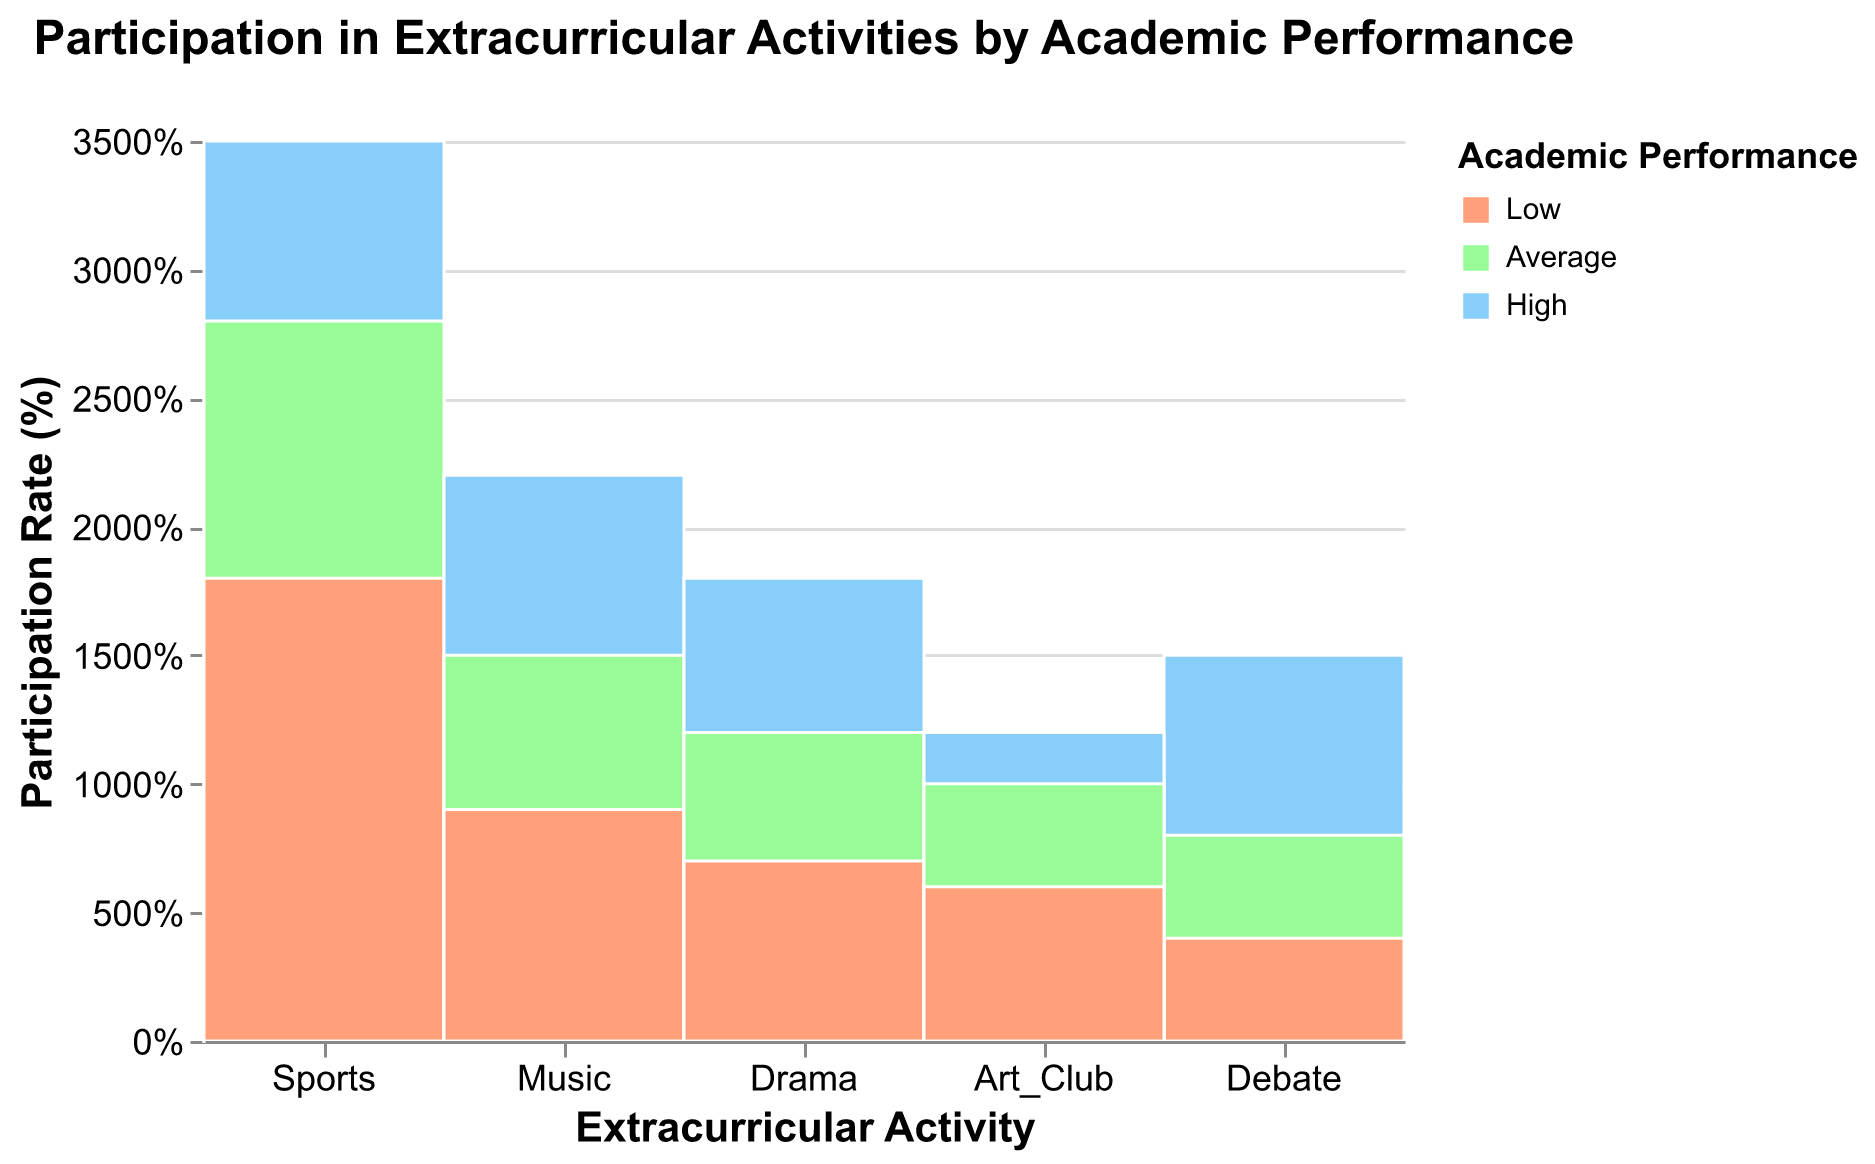What are the most common activities among students with high academic performance? To find the most common activities among students with high academic performance, look at the segments corresponding to 'High' academic performance in each 'Activity'. The height of these segments indicates the participation rate. Sports has the highest participation rate, followed by Music and Drama.
Answer: Sports Which activity has the highest participation rate for students with low academic performance? Look for the 'Low' academic performance segments in each activity column. The tallest segment indicates the highest participation rate for students with low academic performance, which is for Sports.
Answer: Sports How does the participation rate in Debate compare between students with high and low academic performance? Compare the height of the segments labeled 'High' and 'Low' under the 'Debate' activity. The high performance segment is much taller than the low performance segment, indicating a higher participation rate among high academic performance students.
Answer: Higher for high performance students What percentage of students in Drama have average academic performance? Identify the Drama column and find the segment labeled 'Average'. The tooltip or segment height gives the percentage. From the data, 'Average' academic performance students make up approximately 32.4% of Drama participants.
Answer: 32.4% Does Music have a higher participation rate among students with high academic performance compared to Art Club? Compare the 'High' academic performance segments in both Music and Art Club columns. The segment for Music is taller than that of Art Club, indicating a higher participation rate.
Answer: Yes What is the total participation rate in extracurricular activities for students with average academic performance? Σ (Sports + Music + Drama + Debate + Art Club) for average performance: 28+15+12+8+10 = 73. Sum these participation rates from each activity category.
Answer: 73 Are there any activities where students with low academic performance participate more than those with average academic performance? Examine the segments for activities where 'Low' academic performance is taller than 'Average'. No such activity exists where 'Low' is higher than 'Average'.
Answer: No Among students with low academic performance, what is the participation rate difference between Music and Drama? Refer to the 'Low' academic performance segments for Music and Drama. Subtract the Drama rate (7) from Music rate (9).
Answer: 2 Which activity has the lowest overall participation rate across all academic performance groups? Summarize the segments for each activity and identify the lowest total sum. The total rates are: (Sports: 81, Music: 46, Drama: 37, Debate: 27, Art Club: 28). Debate has the lowest.
Answer: Debate What fraction of students with high academic performance participate in Debate compared to those in Sports? Divide the participation rate for Debate (15) by that for Sports (35) for high academic performance. (15/35).
Answer: 3/7 